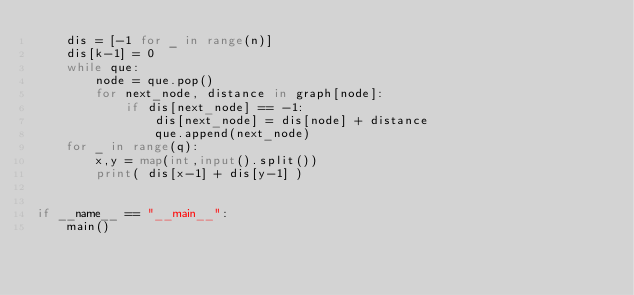Convert code to text. <code><loc_0><loc_0><loc_500><loc_500><_Python_>    dis = [-1 for _ in range(n)]
    dis[k-1] = 0
    while que:
        node = que.pop()
        for next_node, distance in graph[node]:
            if dis[next_node] == -1:
                dis[next_node] = dis[node] + distance
                que.append(next_node)
    for _ in range(q):
        x,y = map(int,input().split())
        print( dis[x-1] + dis[y-1] ) 


if __name__ == "__main__":
    main()</code> 